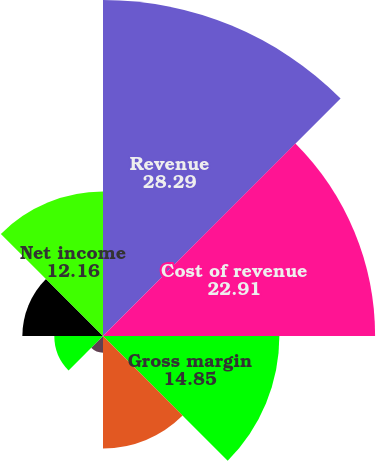<chart> <loc_0><loc_0><loc_500><loc_500><pie_chart><fcel>Revenue<fcel>Cost of revenue<fcel>Gross margin<fcel>Product development<fcel>Marketing and administrative<fcel>Income from operations<fcel>Income before income taxes<fcel>Net income<nl><fcel>28.29%<fcel>22.91%<fcel>14.85%<fcel>9.48%<fcel>1.41%<fcel>4.1%<fcel>6.79%<fcel>12.16%<nl></chart> 